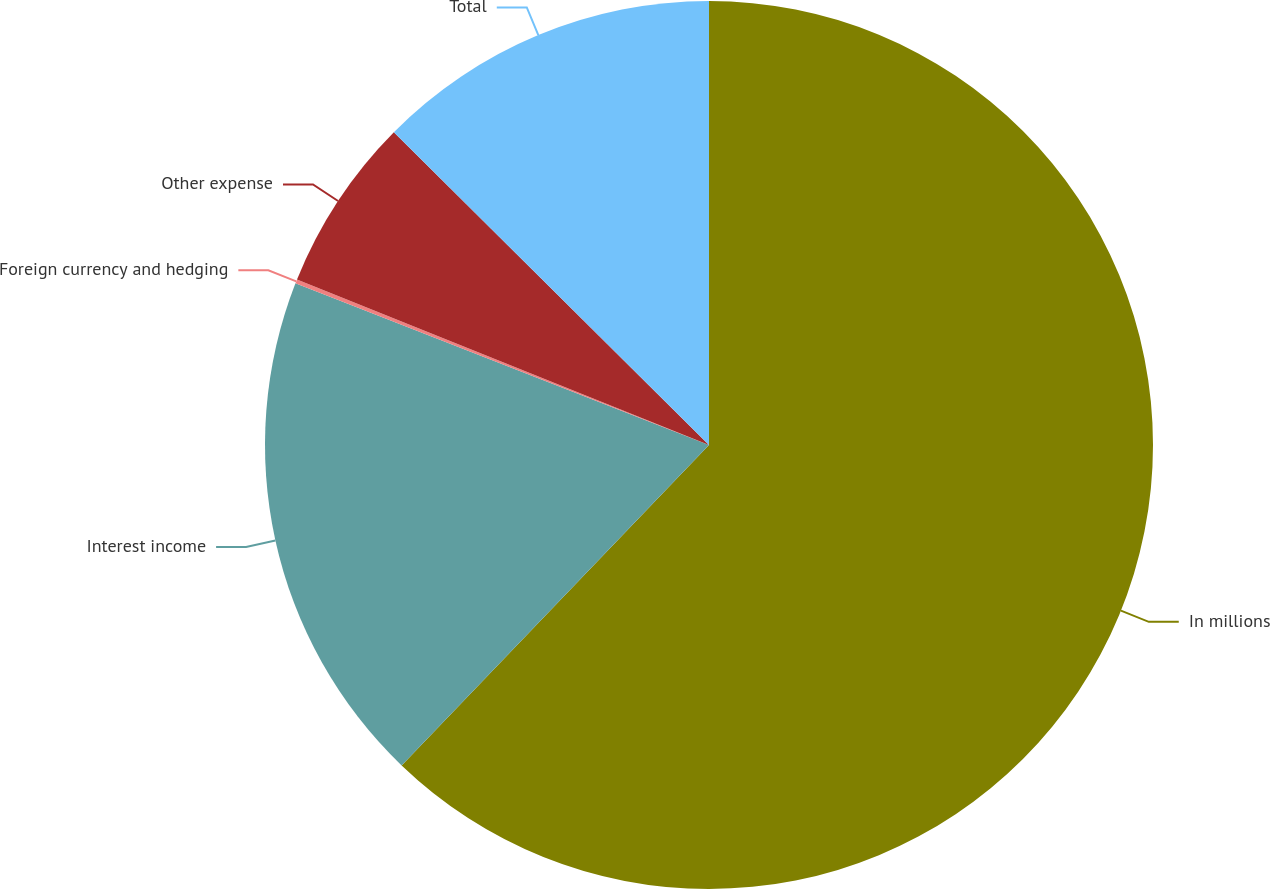Convert chart. <chart><loc_0><loc_0><loc_500><loc_500><pie_chart><fcel>In millions<fcel>Interest income<fcel>Foreign currency and hedging<fcel>Other expense<fcel>Total<nl><fcel>62.17%<fcel>18.76%<fcel>0.15%<fcel>6.36%<fcel>12.56%<nl></chart> 